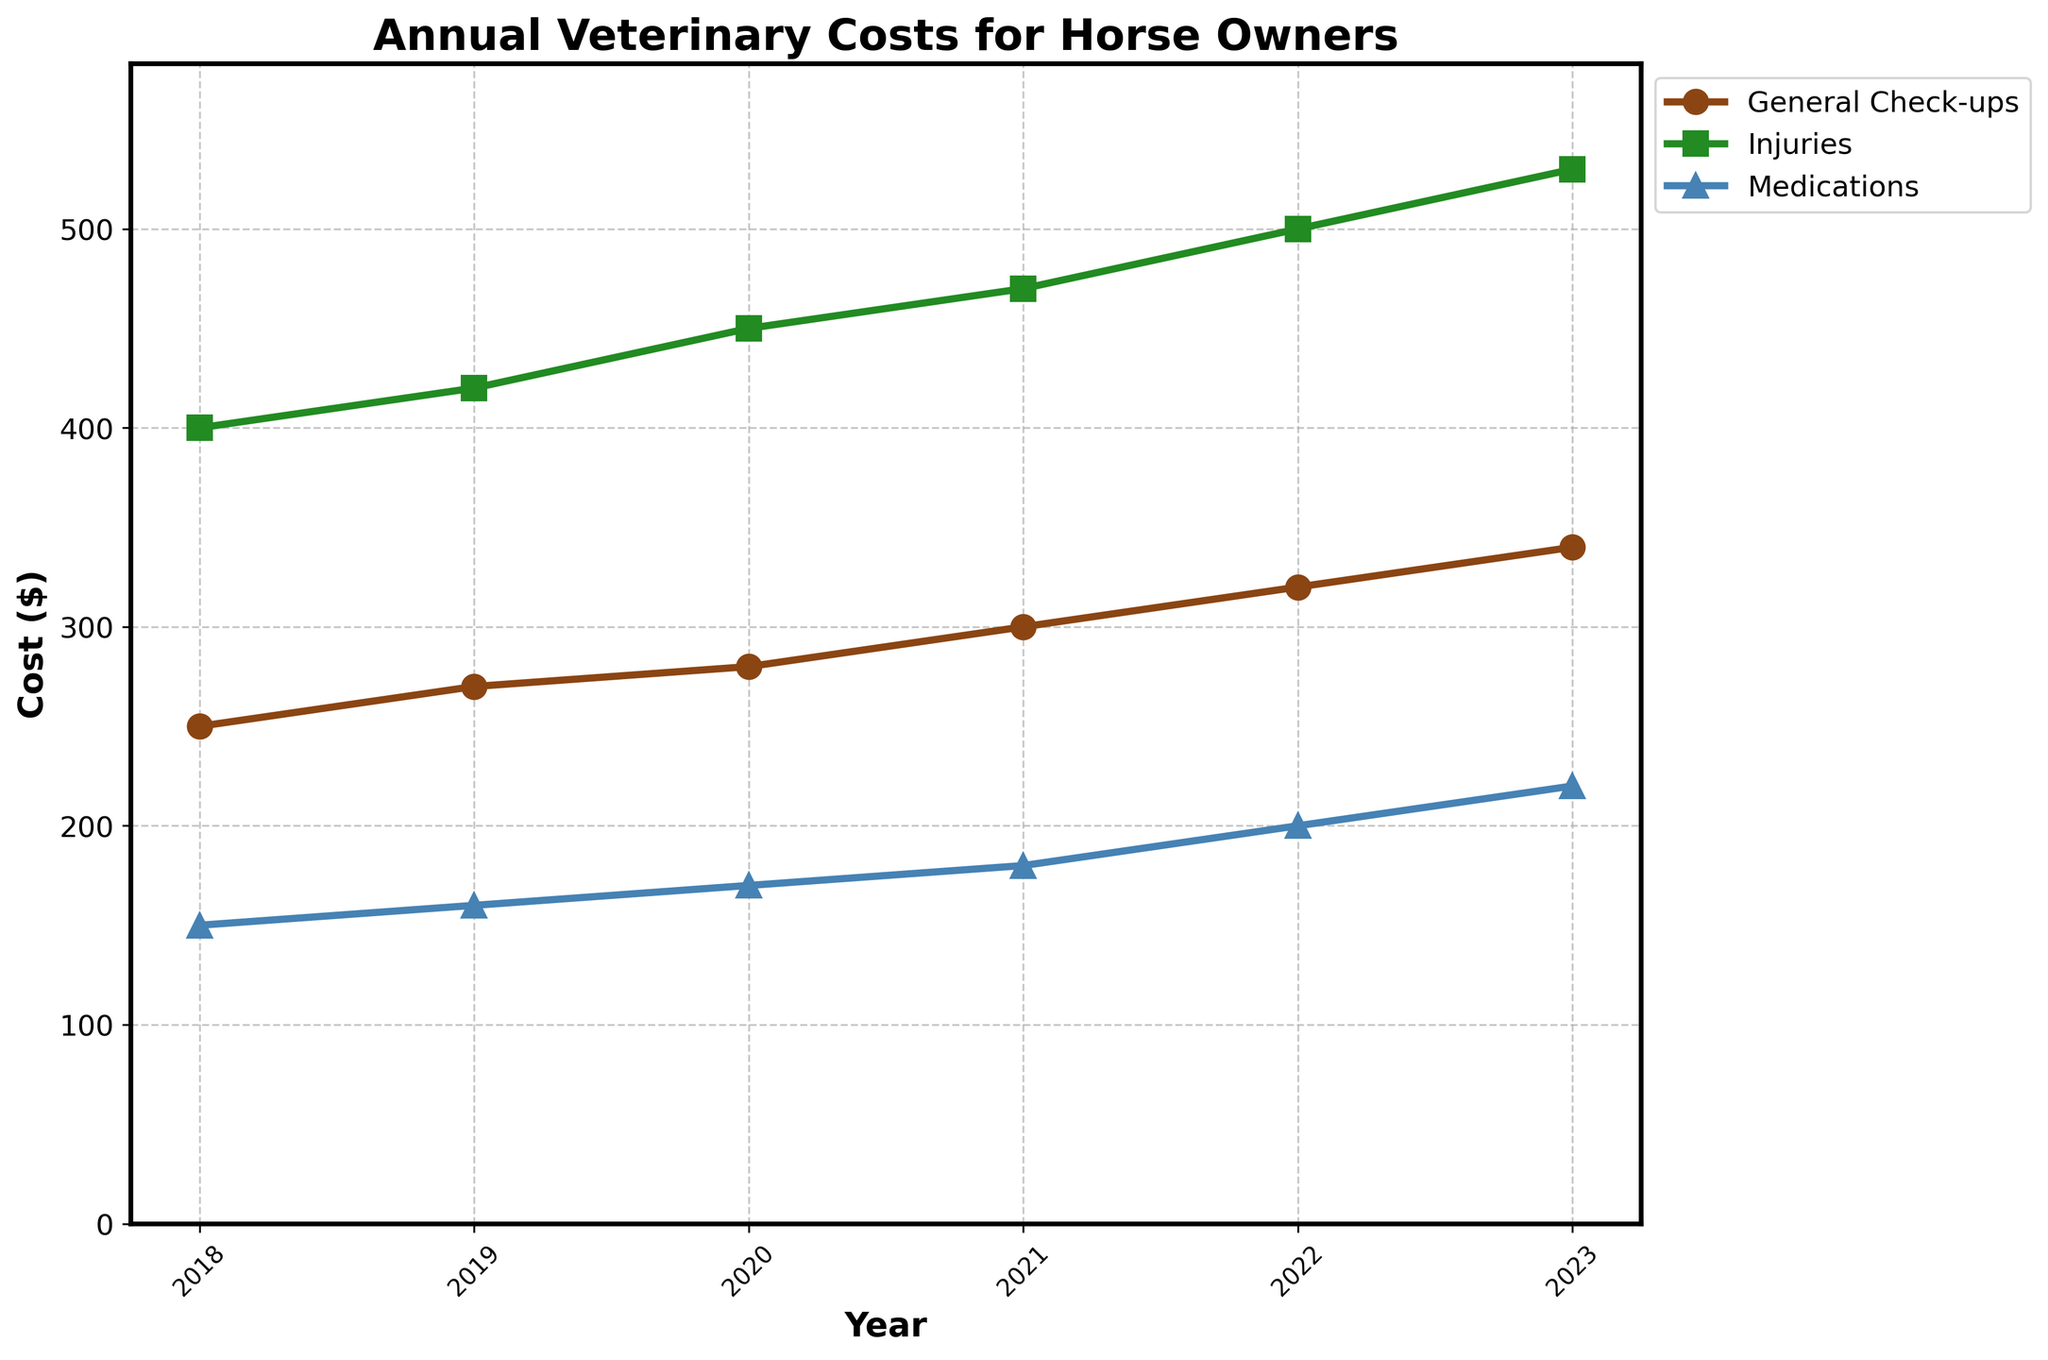What is the title of the figure? The title of the figure is usually located at the top of the plot. From the given code, the title can be extracted directly as 'Annual Veterinary Costs for Horse Owners'.
Answer: Annual Veterinary Costs for Horse Owners Which category has the highest cost in 2023? To answer this, identify the data points for 2023 and compare the values. From 2023 data: General Check-ups is $340, Injuries is $530, and Medications is $220. Hence, ‘Injuries’ has the highest cost.
Answer: Injuries What trend can be observed for the 'General Check-ups' category from 2018 to 2023? To identify the trend, track the costs year by year for 'General Check-ups'. All values are increasing year by year: $250 (2018), $270 (2019), $280 (2020), $300 (2021), $320 (2022), and $340 (2023). Hence, costs are rising.
Answer: Increasing What is the total veterinary cost in 2020? Add the costs of all categories for the year 2020. The costs are $280 (General Check-ups) + $450 (Injuries) + $170 (Medications).
Answer: $900 Which year experienced the largest overall increment in 'Injuries' costs compared to the previous year? Evaluate the differences in costs annually for the 'Injuries' category: from 2018-2019, it’s $20; from 2019-2020, it’s $30; from 2020-2021, it’s $20; from 2021-2022, it’s $30; from 2022-2023, it’s $30. The largest is $30, observed in 2019-2020, 2021-2022, and 2022-2023.
Answer: 2019-2020, 2021-2022, 2022-2023 In which year were the costs for 'Medications' the least, and what was the corresponding value? To find the lowest cost for 'Medications', compare yearly: $150 (2018), $160 (2019), $170 (2020), $180 (2021), $200 (2022), $220 (2023). The lowest is in 2018.
Answer: 2018 and $150 How much did the ‘General Check-ups’ cost increase from 2018 to 2023? Subtract the cost in 2018 from the cost in 2023 for 'General Check-ups'. $340 (2023) - $250 (2018).
Answer: $90 Between which consecutive years did 'Medications' costs increase the most? Assess yearly differences: from 2018-2019, it’s $10; from 2019-2020, it’s $10; from 2020-2021, it’s $10; from 2021-2022, it’s $20; from 2022-2023, it’s $20. So the largest increase was between 2021-2022 and 2022-2023.
Answer: 2021-2022, 2022-2023 Which cost category generally had the minimal fluctuation over the years? Look at annual changes for each category. 'General Check-ups' and 'Medications' changes are more gradual compared to 'Injuries', which shows larger increments. Both 'General Check-ups' and 'Medications' are more stable but 'General Check-ups' shows slightly steadier increases.
Answer: General Check-ups 